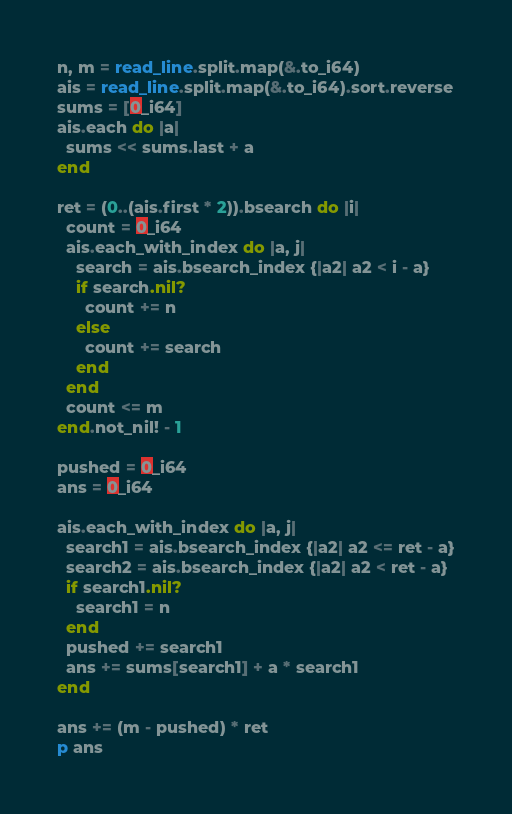Convert code to text. <code><loc_0><loc_0><loc_500><loc_500><_Crystal_>n, m = read_line.split.map(&.to_i64)
ais = read_line.split.map(&.to_i64).sort.reverse
sums = [0_i64]
ais.each do |a|
  sums << sums.last + a
end

ret = (0..(ais.first * 2)).bsearch do |i|
  count = 0_i64
  ais.each_with_index do |a, j|
    search = ais.bsearch_index {|a2| a2 < i - a}
    if search.nil?
      count += n
    else
      count += search
    end
  end
  count <= m
end.not_nil! - 1

pushed = 0_i64
ans = 0_i64

ais.each_with_index do |a, j|
  search1 = ais.bsearch_index {|a2| a2 <= ret - a}
  search2 = ais.bsearch_index {|a2| a2 < ret - a}
  if search1.nil?
    search1 = n
  end
  pushed += search1
  ans += sums[search1] + a * search1
end

ans += (m - pushed) * ret
p ans
</code> 